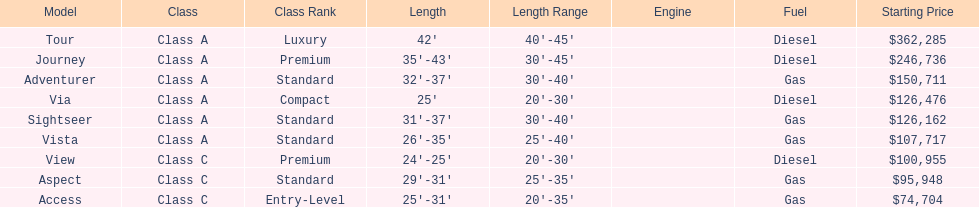Does the tour take diesel or gas? Diesel. 